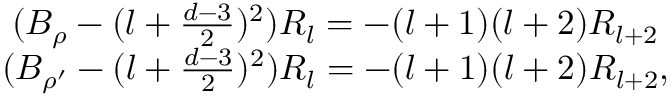<formula> <loc_0><loc_0><loc_500><loc_500>\begin{array} { c } { { ( B _ { \rho } - ( l + \frac { d - 3 } { 2 } ) ^ { 2 } ) R _ { l } = - ( l + 1 ) ( l + 2 ) R _ { l + 2 } } } \\ { { ( B _ { \rho ^ { \prime } } - ( l + \frac { d - 3 } { 2 } ) ^ { 2 } ) R _ { l } = - ( l + 1 ) ( l + 2 ) R _ { l + 2 } , } } \end{array}</formula> 